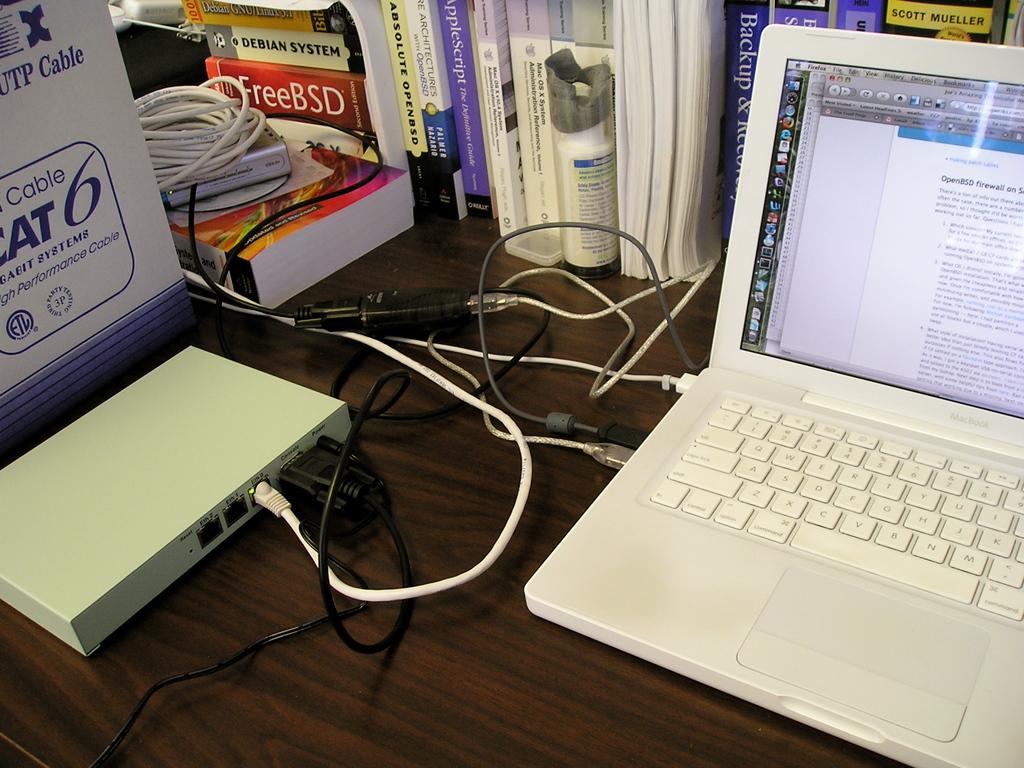What does the red book say?
Your answer should be compact. Freebsd. What number is on the blue and white box on the left?
Ensure brevity in your answer.  6. 